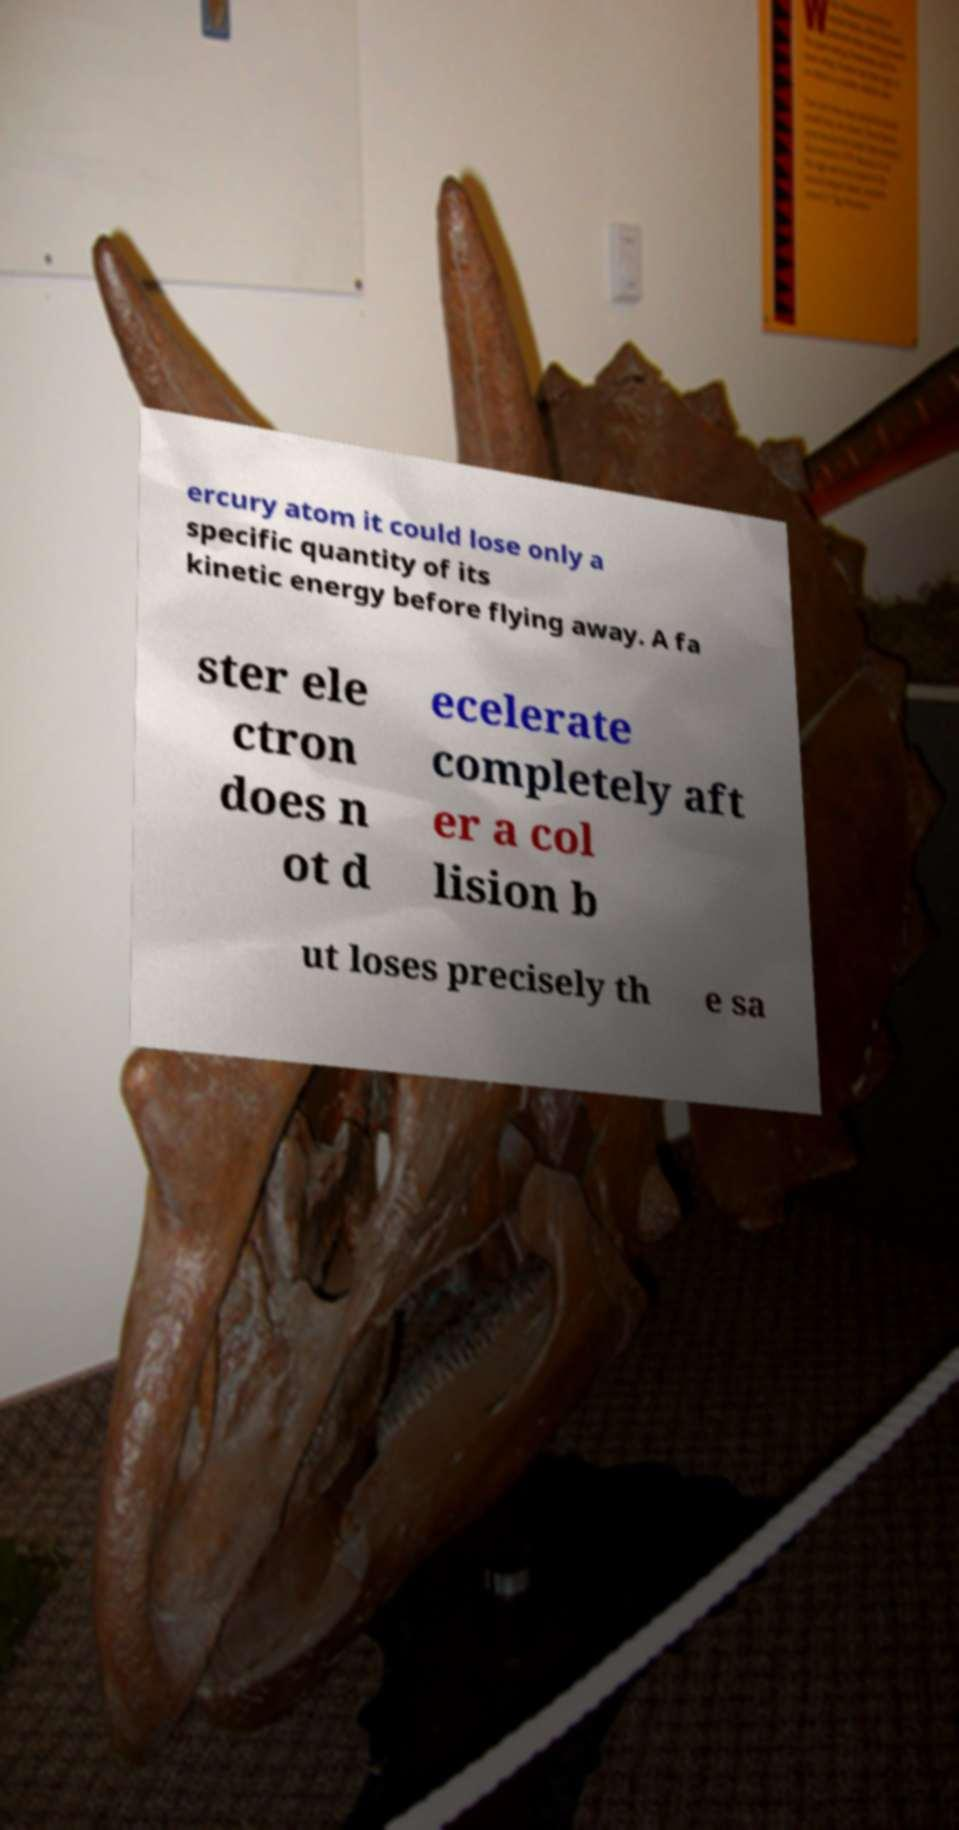Could you extract and type out the text from this image? ercury atom it could lose only a specific quantity of its kinetic energy before flying away. A fa ster ele ctron does n ot d ecelerate completely aft er a col lision b ut loses precisely th e sa 